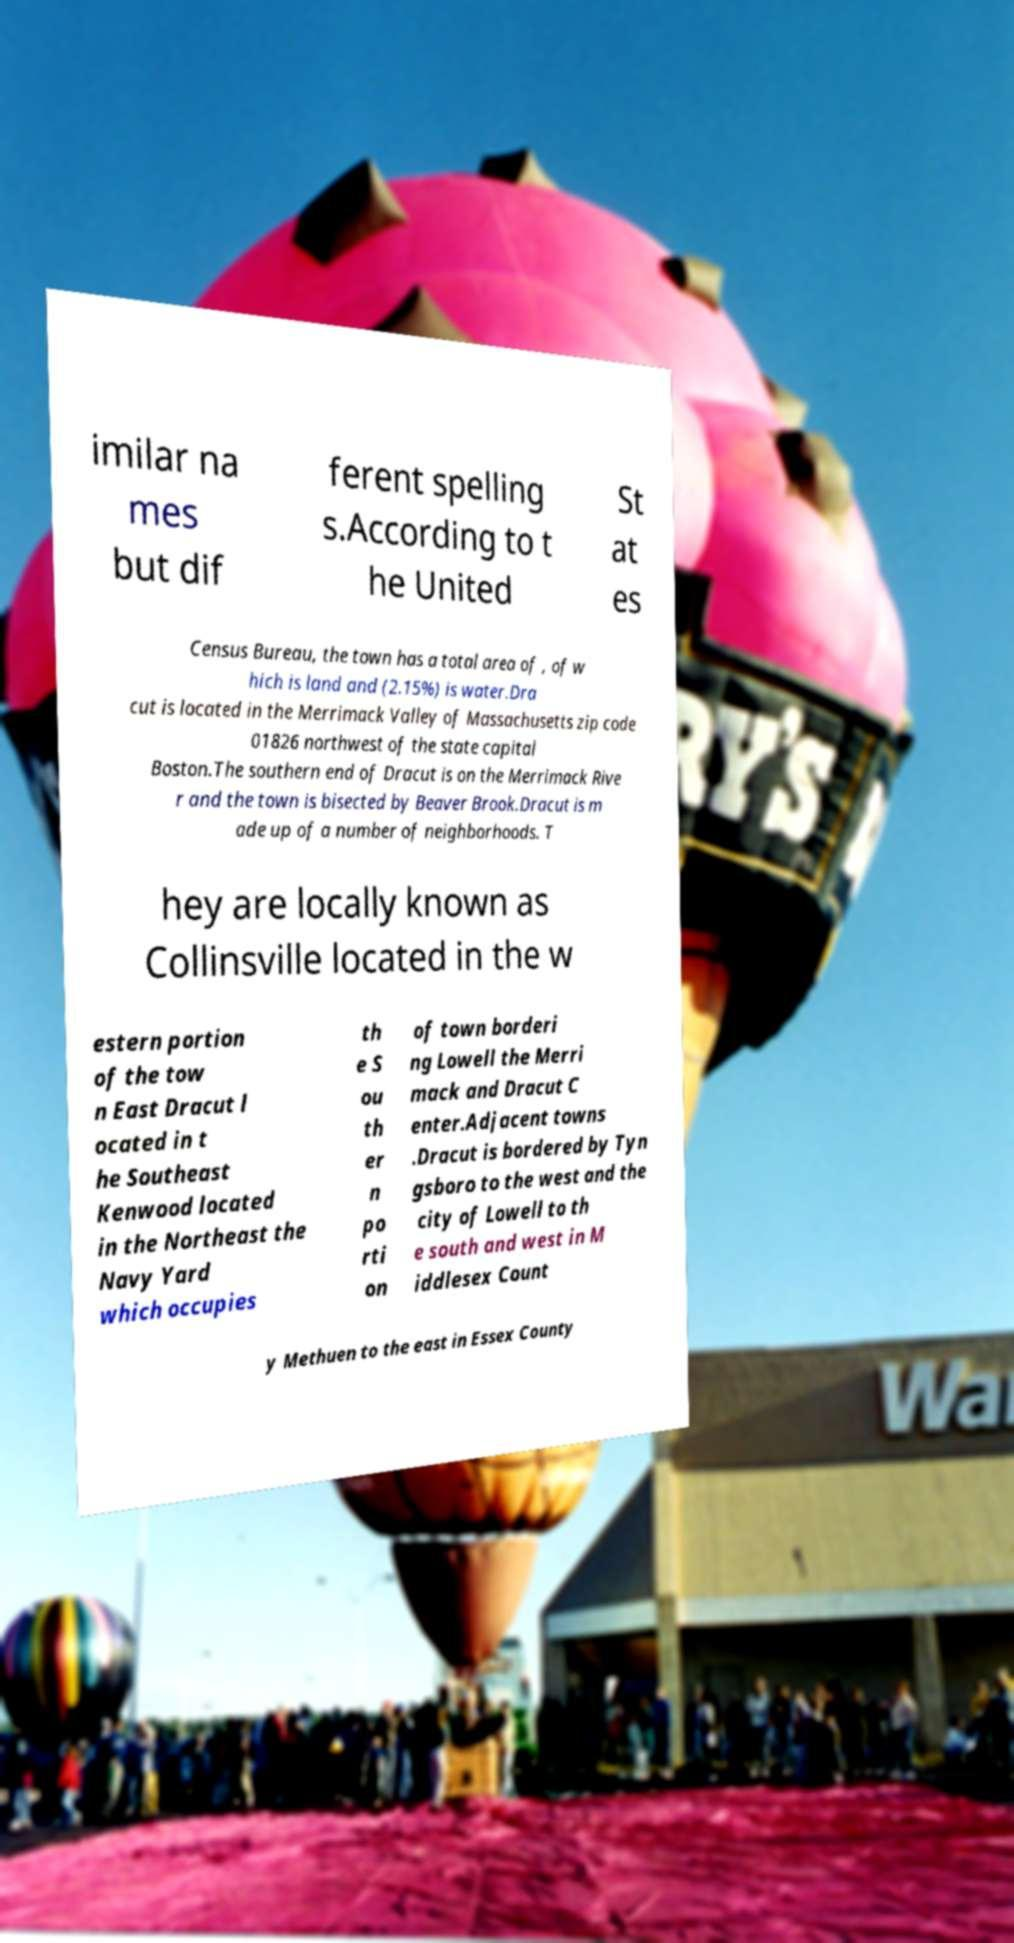Could you extract and type out the text from this image? imilar na mes but dif ferent spelling s.According to t he United St at es Census Bureau, the town has a total area of , of w hich is land and (2.15%) is water.Dra cut is located in the Merrimack Valley of Massachusetts zip code 01826 northwest of the state capital Boston.The southern end of Dracut is on the Merrimack Rive r and the town is bisected by Beaver Brook.Dracut is m ade up of a number of neighborhoods. T hey are locally known as Collinsville located in the w estern portion of the tow n East Dracut l ocated in t he Southeast Kenwood located in the Northeast the Navy Yard which occupies th e S ou th er n po rti on of town borderi ng Lowell the Merri mack and Dracut C enter.Adjacent towns .Dracut is bordered by Tyn gsboro to the west and the city of Lowell to th e south and west in M iddlesex Count y Methuen to the east in Essex County 